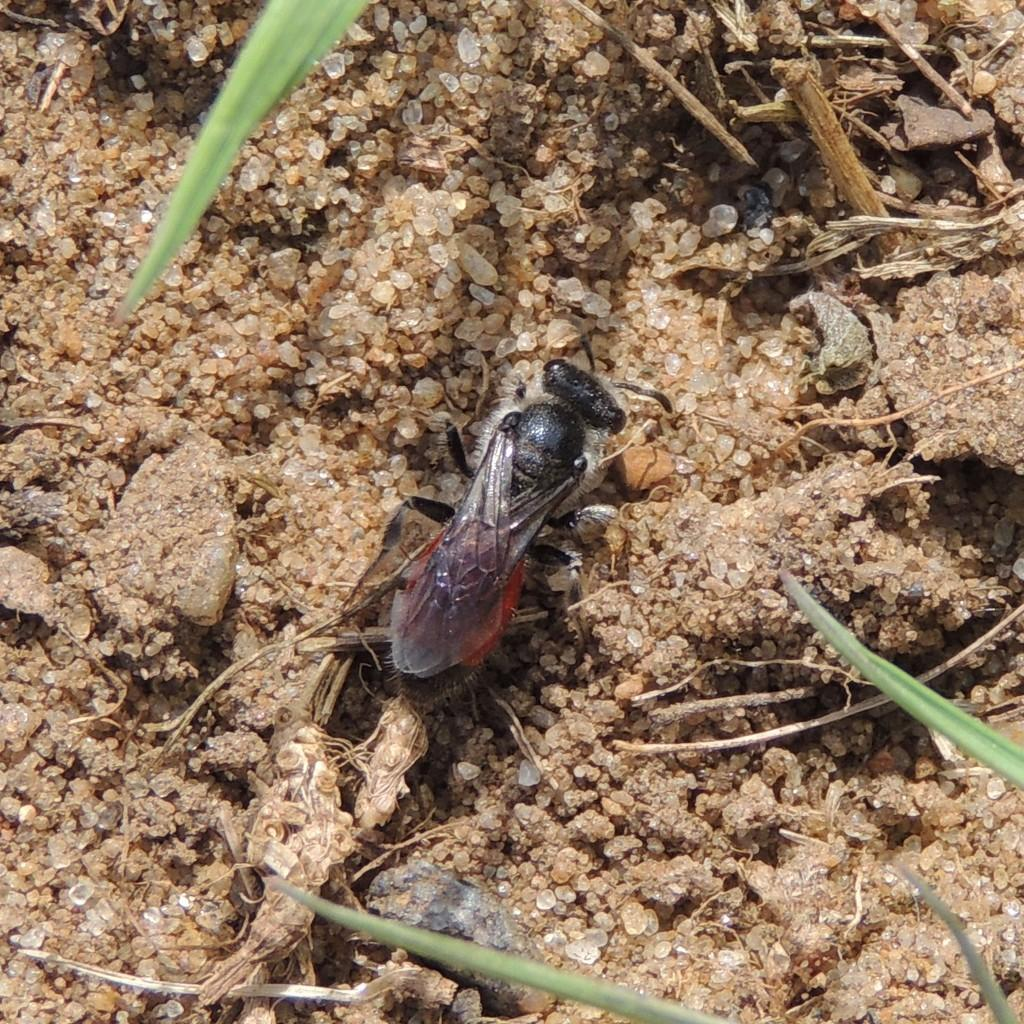What type of creature can be seen on the ground in the image? There is an insect on the ground in the image. What other objects can be seen in the image? There are stones, wood, and leaves in the image. How many brothers does the insect have in the image? There is no information about the insect's family in the image, so we cannot determine the number of brothers it has. 